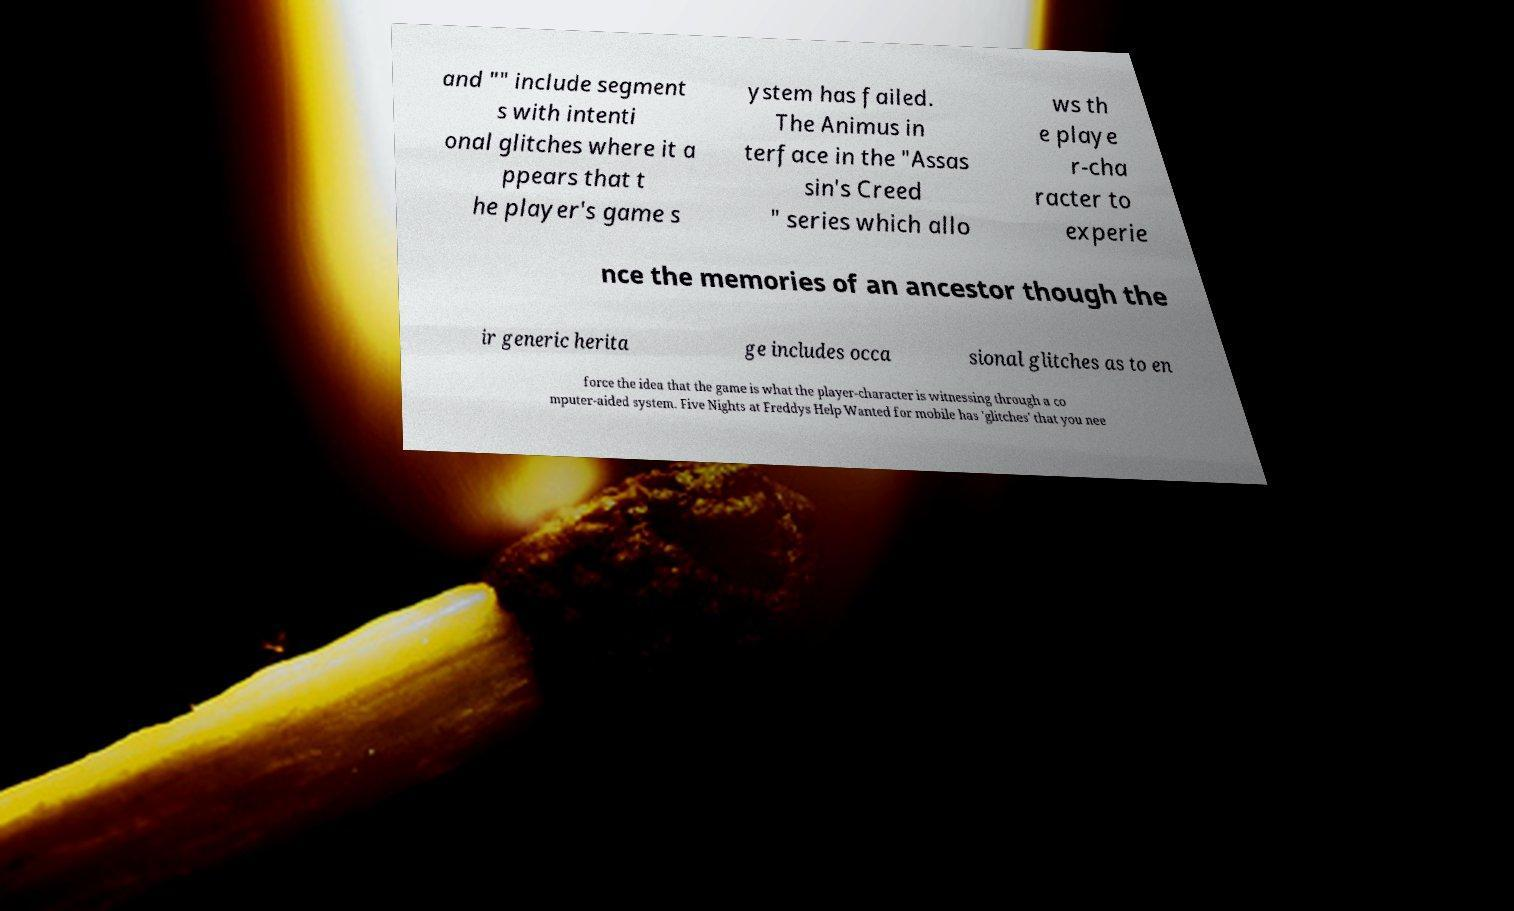There's text embedded in this image that I need extracted. Can you transcribe it verbatim? and "" include segment s with intenti onal glitches where it a ppears that t he player's game s ystem has failed. The Animus in terface in the "Assas sin's Creed " series which allo ws th e playe r-cha racter to experie nce the memories of an ancestor though the ir generic herita ge includes occa sional glitches as to en force the idea that the game is what the player-character is witnessing through a co mputer-aided system. Five Nights at Freddys Help Wanted for mobile has 'glitches' that you nee 